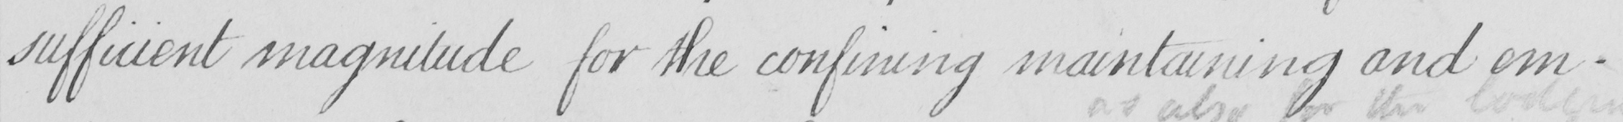What does this handwritten line say? sufficient magnitude for the confining maintaining and em- 